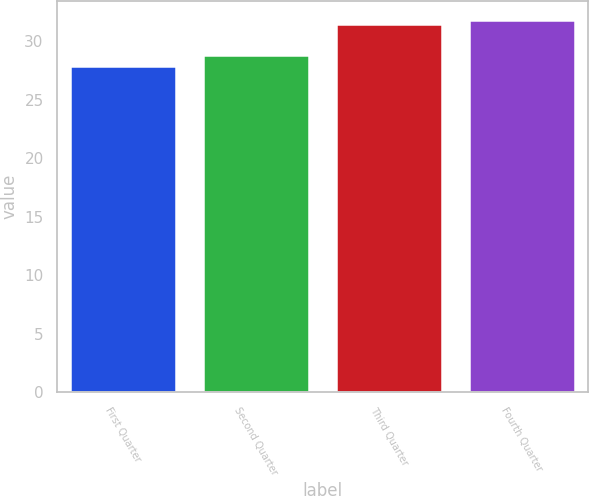Convert chart to OTSL. <chart><loc_0><loc_0><loc_500><loc_500><bar_chart><fcel>First Quarter<fcel>Second Quarter<fcel>Third Quarter<fcel>Fourth Quarter<nl><fcel>27.89<fcel>28.82<fcel>31.46<fcel>31.82<nl></chart> 